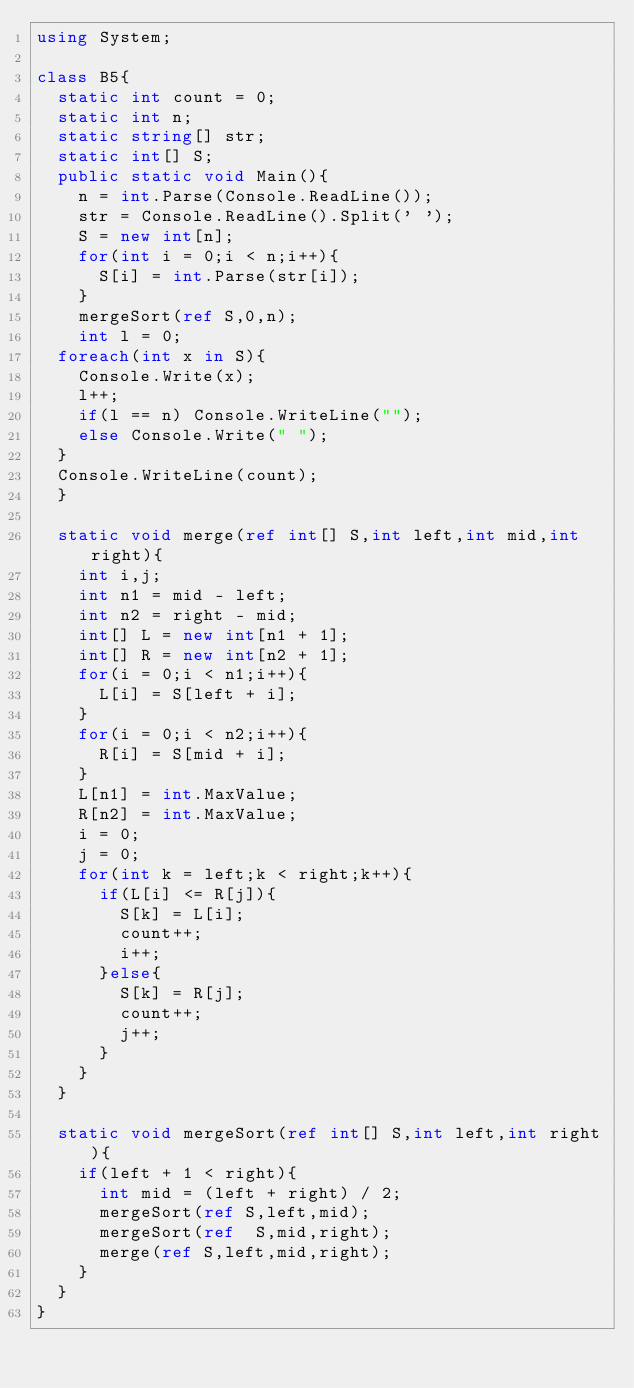<code> <loc_0><loc_0><loc_500><loc_500><_C#_>using System;

class B5{
  static int count = 0;
  static int n;
  static string[] str;
  static int[] S;
  public static void Main(){
    n = int.Parse(Console.ReadLine());
    str = Console.ReadLine().Split(' ');
    S = new int[n];
    for(int i = 0;i < n;i++){
      S[i] = int.Parse(str[i]);
    }
    mergeSort(ref S,0,n);
    int l = 0;
  foreach(int x in S){
    Console.Write(x);
    l++;
    if(l == n) Console.WriteLine("");
    else Console.Write(" ");
  }
  Console.WriteLine(count);
  }

  static void merge(ref int[] S,int left,int mid,int right){
    int i,j;
    int n1 = mid - left;
    int n2 = right - mid;
    int[] L = new int[n1 + 1];
    int[] R = new int[n2 + 1];
    for(i = 0;i < n1;i++){
      L[i] = S[left + i];
    }
    for(i = 0;i < n2;i++){
      R[i] = S[mid + i];
    }
    L[n1] = int.MaxValue;
    R[n2] = int.MaxValue;
    i = 0;
    j = 0;
    for(int k = left;k < right;k++){
      if(L[i] <= R[j]){
        S[k] = L[i];
        count++;
        i++;
      }else{
        S[k] = R[j];
        count++;
        j++;
      }
    }
  }

  static void mergeSort(ref int[] S,int left,int right){
    if(left + 1 < right){
      int mid = (left + right) / 2;
      mergeSort(ref S,left,mid);
      mergeSort(ref  S,mid,right);
      merge(ref S,left,mid,right);
    }
  }
}

</code> 